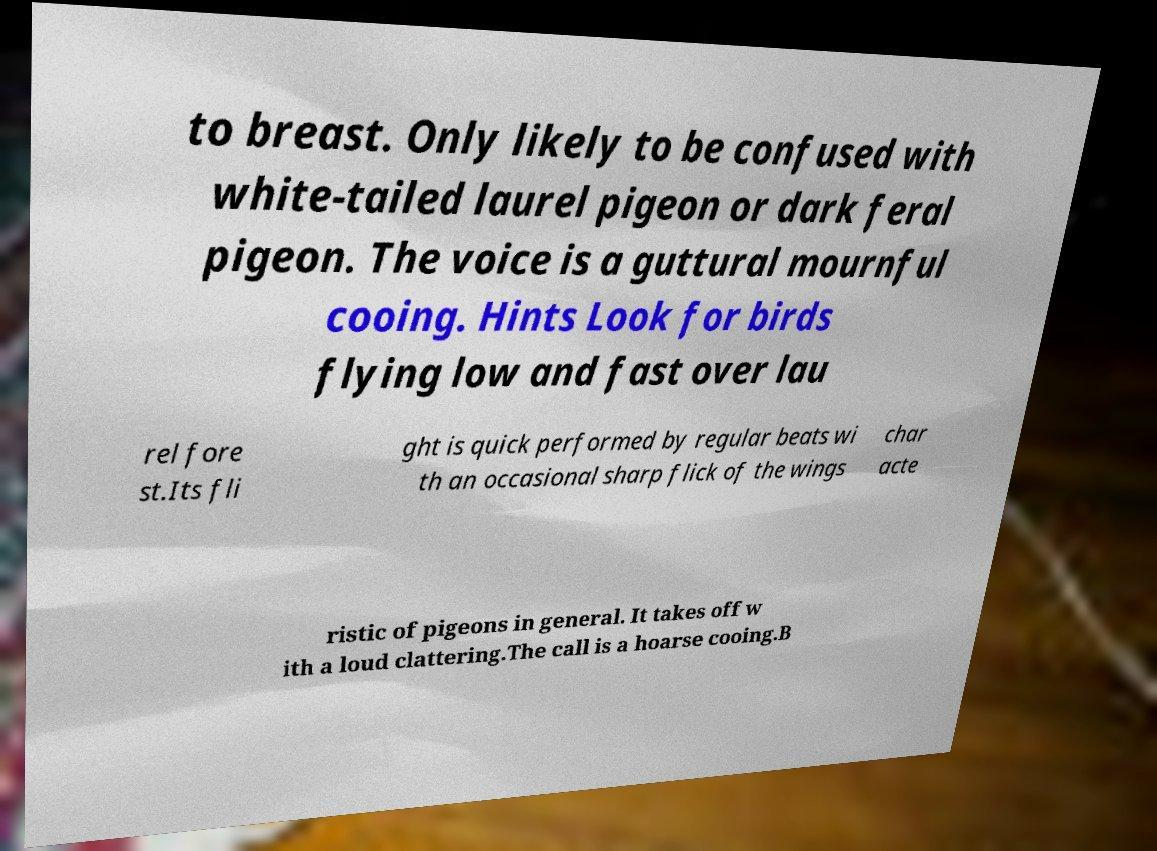There's text embedded in this image that I need extracted. Can you transcribe it verbatim? to breast. Only likely to be confused with white-tailed laurel pigeon or dark feral pigeon. The voice is a guttural mournful cooing. Hints Look for birds flying low and fast over lau rel fore st.Its fli ght is quick performed by regular beats wi th an occasional sharp flick of the wings char acte ristic of pigeons in general. It takes off w ith a loud clattering.The call is a hoarse cooing.B 